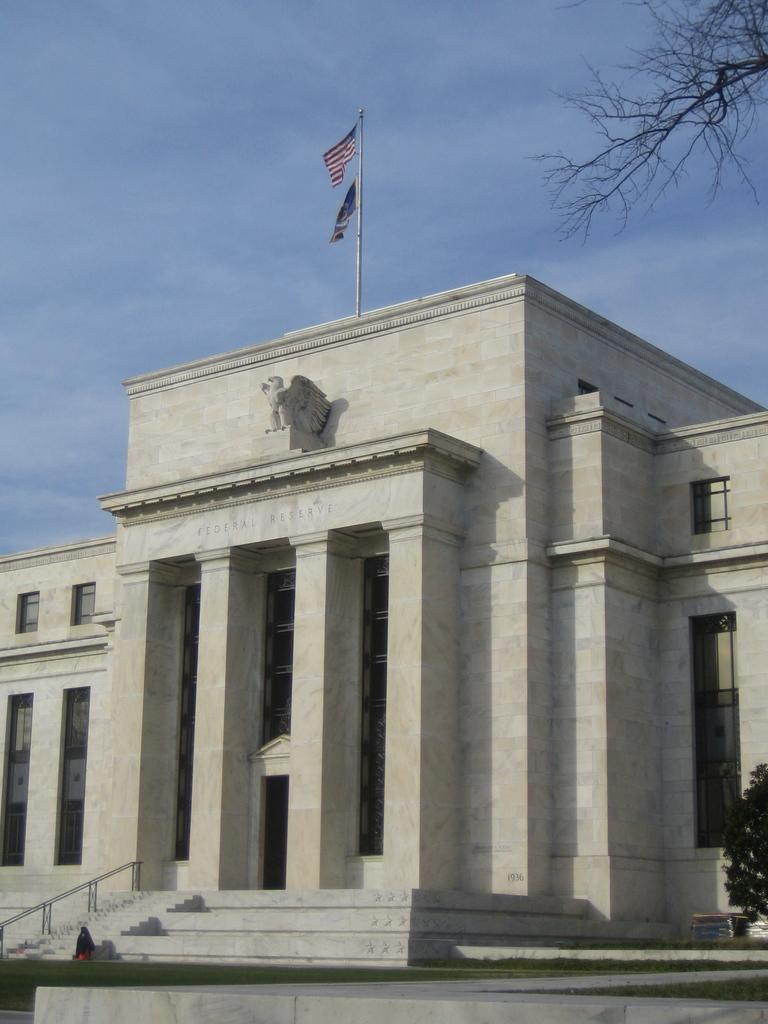What organization is depicted in the image? The image contains the Central Bank of the United States. Is there any symbol of the United States on the organization? Yes, there is a flag of the USA on the organization. What can be seen on the right side of the image? There is a plant in front of the organization on the right side. Can you describe the crowd gathered around the Central Bank in the image? There is no crowd present in the image; it only shows the Central Bank, the USA flag, and a plant on the right side. How many chairs are visible in the image? There are no chairs visible in the image. 